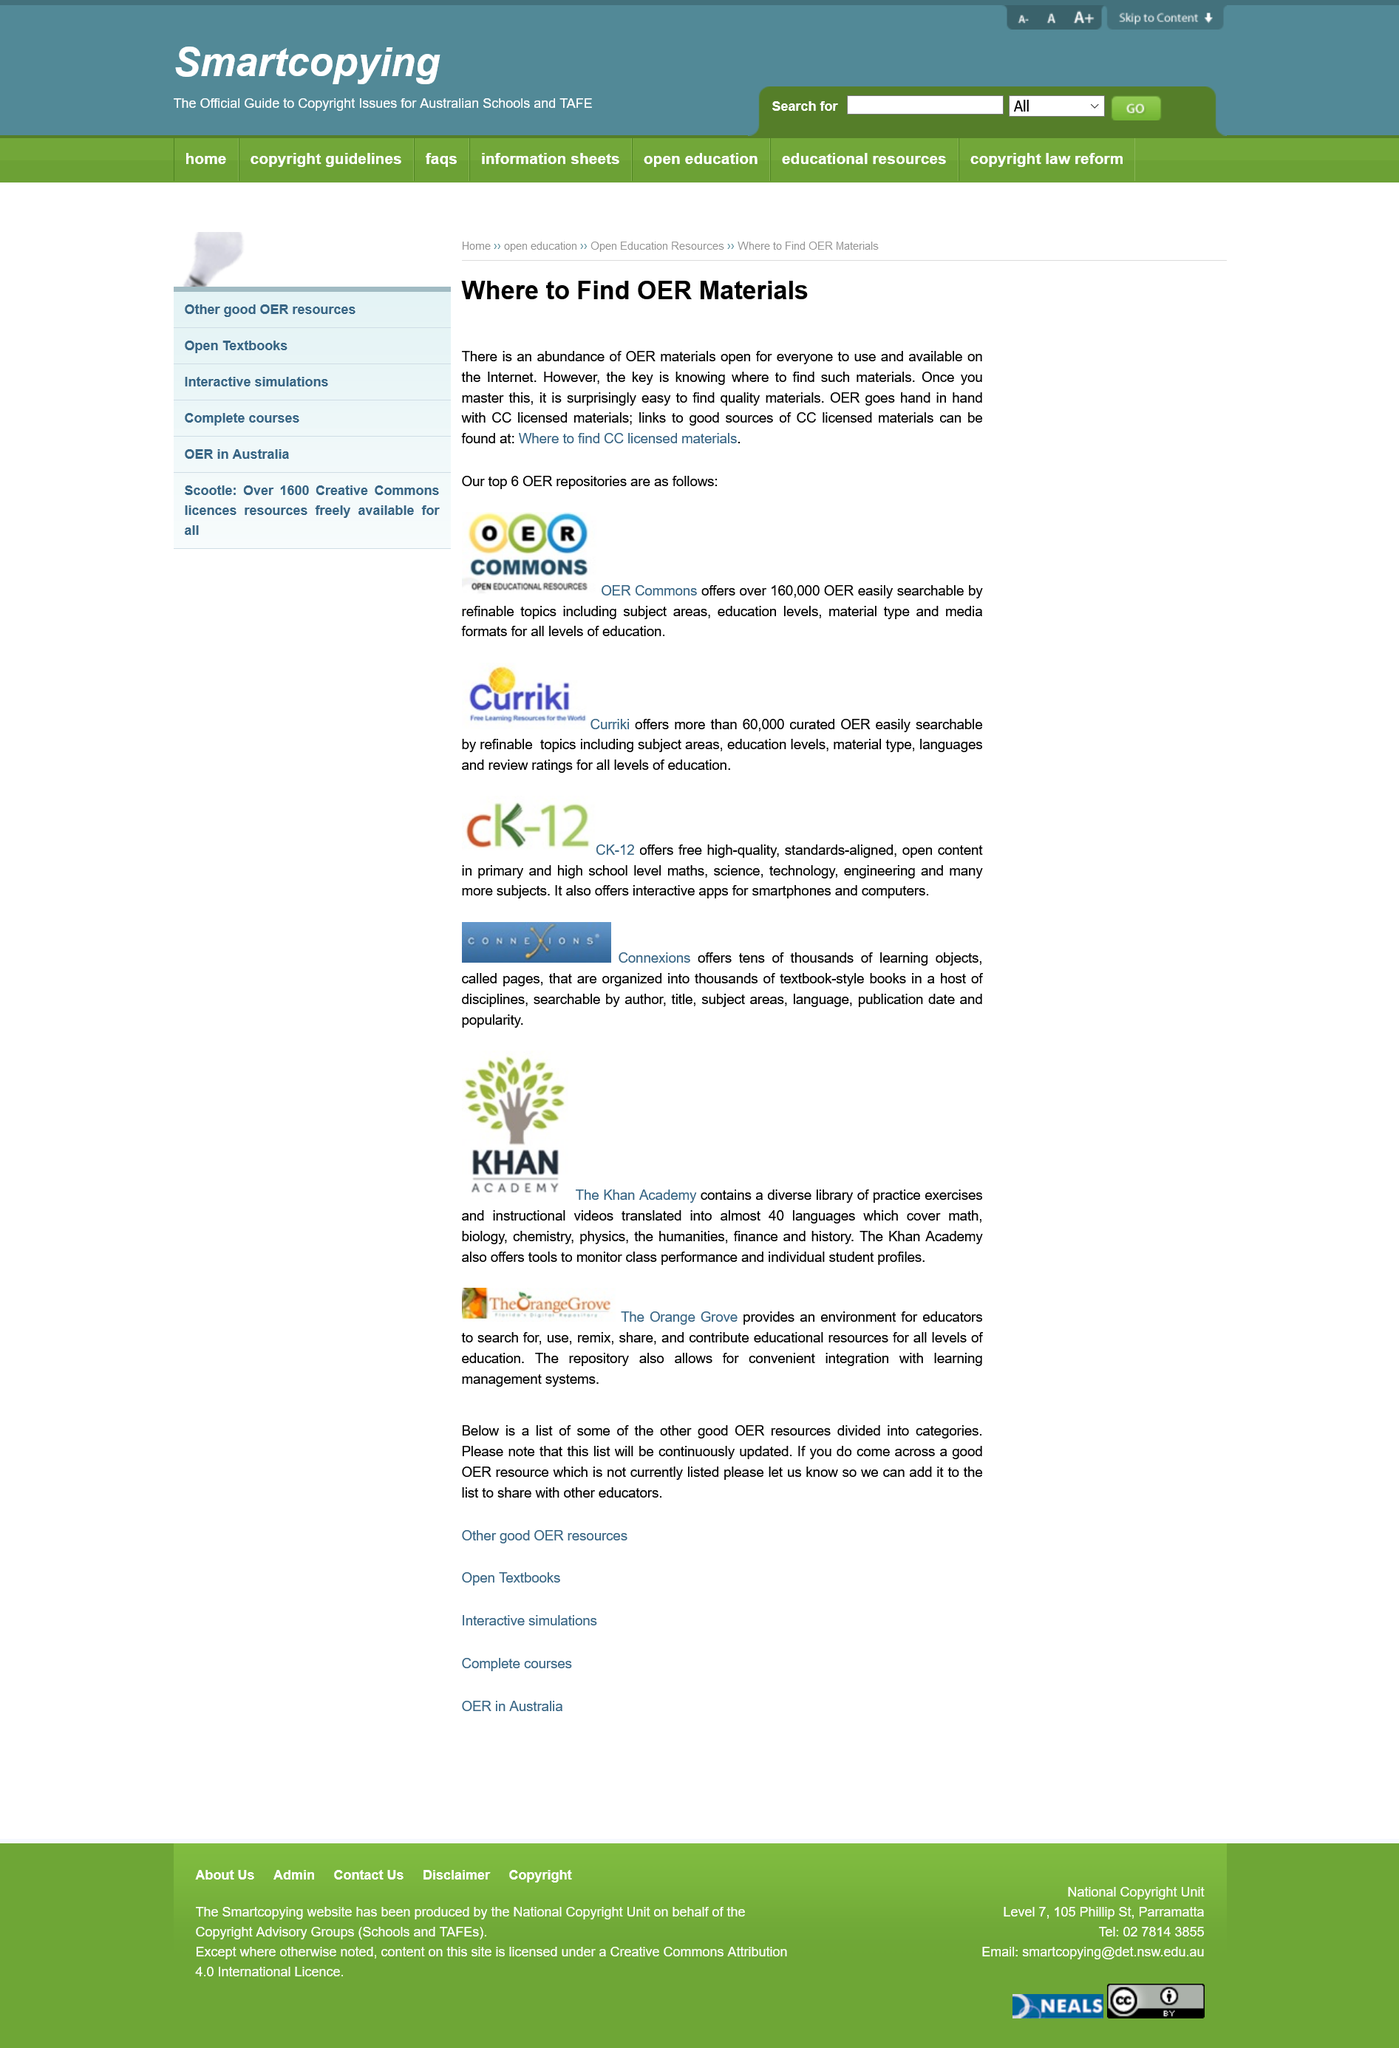Identify some key points in this picture. The Orange Grove is a platform that offers a space for educators to discover, utilize, modify, distribute, and contribute educational resources for all levels of education. The repository allows for convenient integration with learning management systems. Open Educational Resources refers to a collection of materials that are made freely available for everyone to use, modify, and distribute without any copyright restrictions. Open Educational Resources (OER) and CC licensed materials are inseparable and mutually reinforcing. OER Commons offers over 160,000 Open Educational Resources, making it a valuable resource for those seeking Open Educational Resources. 